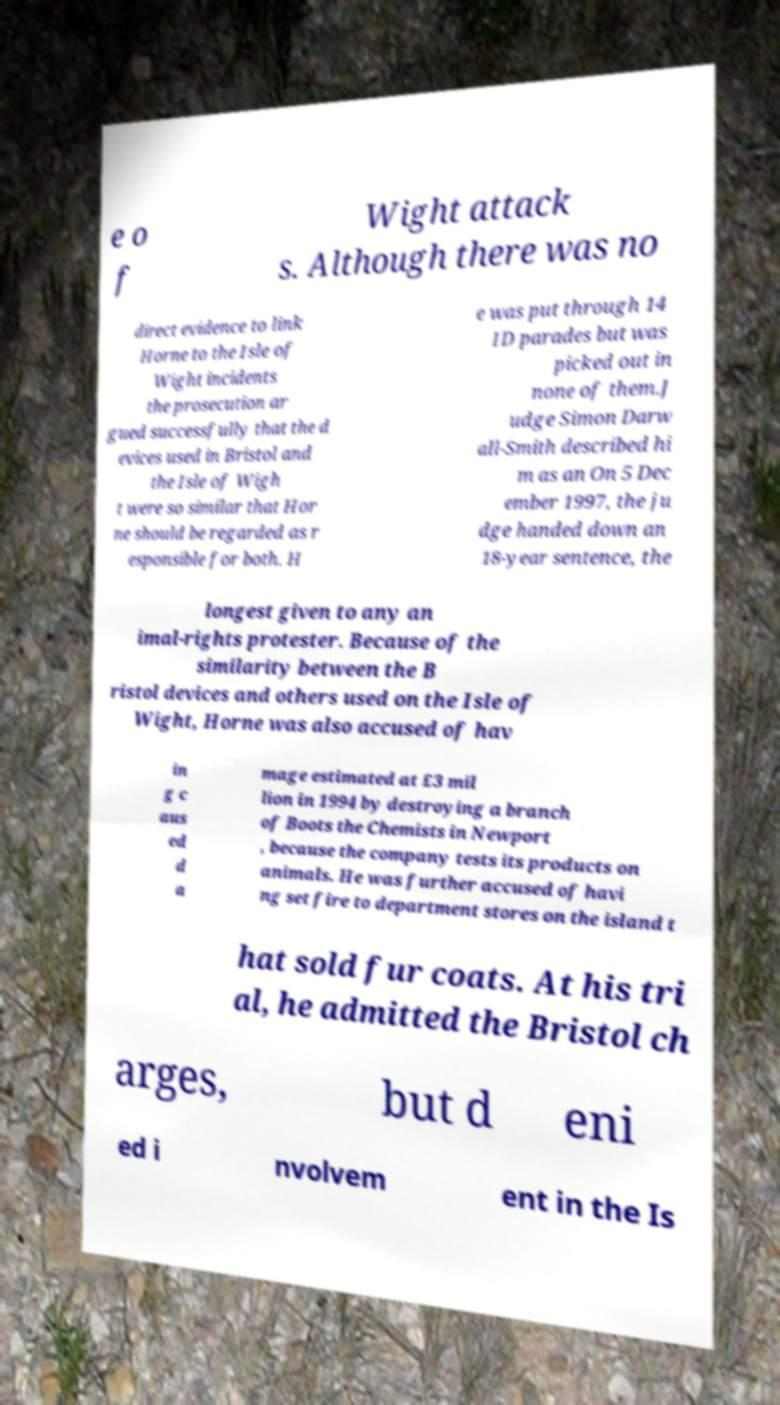Could you assist in decoding the text presented in this image and type it out clearly? e o f Wight attack s. Although there was no direct evidence to link Horne to the Isle of Wight incidents the prosecution ar gued successfully that the d evices used in Bristol and the Isle of Wigh t were so similar that Hor ne should be regarded as r esponsible for both. H e was put through 14 ID parades but was picked out in none of them.J udge Simon Darw all-Smith described hi m as an On 5 Dec ember 1997, the ju dge handed down an 18-year sentence, the longest given to any an imal-rights protester. Because of the similarity between the B ristol devices and others used on the Isle of Wight, Horne was also accused of hav in g c aus ed d a mage estimated at £3 mil lion in 1994 by destroying a branch of Boots the Chemists in Newport , because the company tests its products on animals. He was further accused of havi ng set fire to department stores on the island t hat sold fur coats. At his tri al, he admitted the Bristol ch arges, but d eni ed i nvolvem ent in the Is 